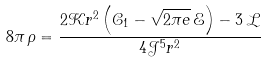Convert formula to latex. <formula><loc_0><loc_0><loc_500><loc_500>8 \pi \, \rho = { \frac { 2 \mathcal { K } r ^ { 2 } \left ( \mathcal { C } _ { 1 } - \sqrt { 2 \pi e } \, \mathcal { E } \right ) - 3 \, \mathcal { L } } { 4 \mathcal { J } ^ { 5 } r ^ { 2 } } }</formula> 